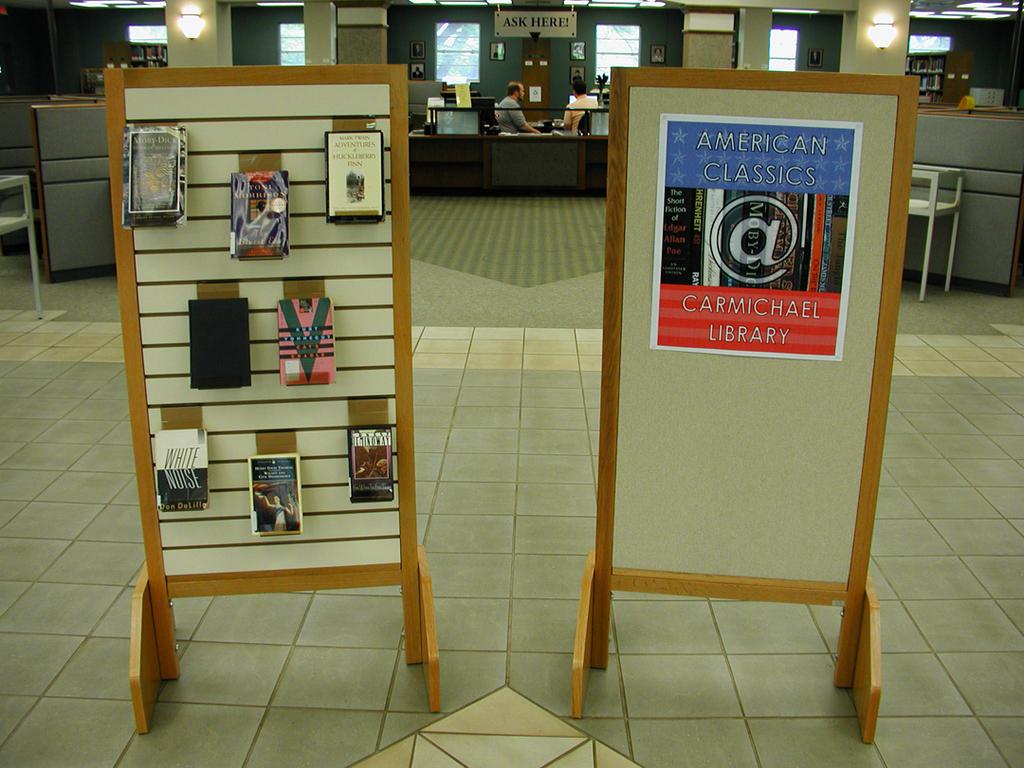What is the name of this library?
Ensure brevity in your answer.  Carmichael library. What can you do at the desk?
Your answer should be very brief. Ask. 